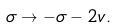Convert formula to latex. <formula><loc_0><loc_0><loc_500><loc_500>\sigma \rightarrow - \sigma - 2 v .</formula> 